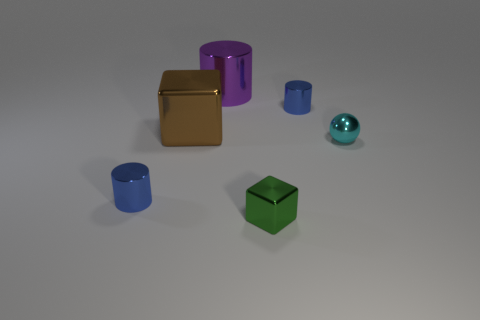What number of big purple things are the same material as the green thing?
Offer a terse response. 1. Is the size of the green object the same as the ball?
Your answer should be very brief. Yes. What color is the small metallic ball?
Your answer should be compact. Cyan. How many things are either blue things or cyan metal cylinders?
Offer a very short reply. 2. Are there any tiny gray metallic objects of the same shape as the brown shiny object?
Provide a short and direct response. No. The tiny blue shiny thing that is right of the small blue thing in front of the tiny cyan metal object is what shape?
Keep it short and to the point. Cylinder. Is there another thing of the same size as the cyan metal object?
Offer a terse response. Yes. Is the number of large brown things less than the number of small shiny things?
Your response must be concise. Yes. What is the shape of the large object behind the blue object that is right of the metallic block to the left of the purple thing?
Ensure brevity in your answer.  Cylinder. How many objects are either blue shiny cylinders that are on the left side of the small green metal object or tiny cylinders to the left of the small cyan thing?
Your answer should be very brief. 2. 